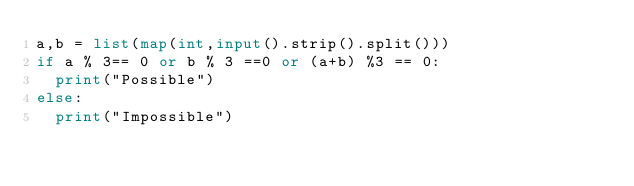Convert code to text. <code><loc_0><loc_0><loc_500><loc_500><_Python_>a,b = list(map(int,input().strip().split()))
if a % 3== 0 or b % 3 ==0 or (a+b) %3 == 0:
  print("Possible")
else:
  print("Impossible")</code> 